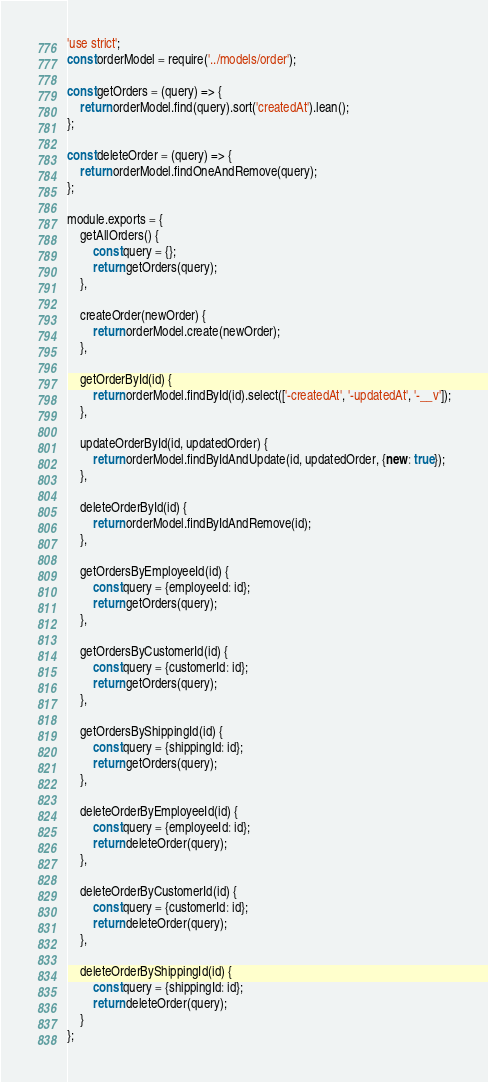<code> <loc_0><loc_0><loc_500><loc_500><_JavaScript_>'use strict';
const orderModel = require('../models/order');

const getOrders = (query) => {
    return orderModel.find(query).sort('createdAt').lean();
};

const deleteOrder = (query) => {
    return orderModel.findOneAndRemove(query);
};

module.exports = {
    getAllOrders() {
        const query = {};
        return getOrders(query);
    },

    createOrder(newOrder) {
        return orderModel.create(newOrder);
    },

    getOrderById(id) {
        return orderModel.findById(id).select(['-createdAt', '-updatedAt', '-__v']);
    },

    updateOrderById(id, updatedOrder) {
        return orderModel.findByIdAndUpdate(id, updatedOrder, {new: true});
    },

    deleteOrderById(id) {
        return orderModel.findByIdAndRemove(id);
    },

    getOrdersByEmployeeId(id) {
        const query = {employeeId: id};
        return getOrders(query);
    },

    getOrdersByCustomerId(id) {
        const query = {customerId: id};
        return getOrders(query);
    },

    getOrdersByShippingId(id) {
        const query = {shippingId: id};
        return getOrders(query);
    },

    deleteOrderByEmployeeId(id) {
        const query = {employeeId: id};
        return deleteOrder(query);
    },

    deleteOrderByCustomerId(id) {
        const query = {customerId: id};
        return deleteOrder(query);
    },

    deleteOrderByShippingId(id) {
        const query = {shippingId: id};
        return deleteOrder(query);
    }
};
</code> 